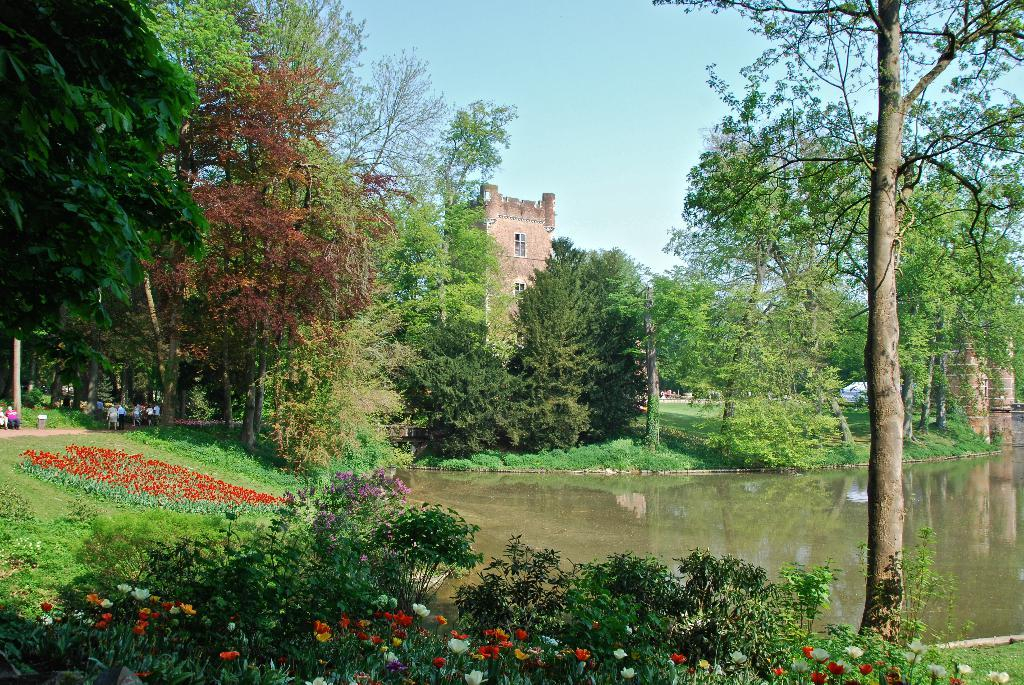What type of plants can be seen in the image? There are flowers in the image. What else can be seen in the image besides the flowers? There is water, trees, a building with windows, and persons visible in the image. Can you describe the building in the image? The building has windows. What is visible in the background of the image? The sky is visible in the background of the image. What is the price of the paste used to create the flowers in the image? There is no mention of paste or its price in the image, as the flowers are real and not created with paste. 